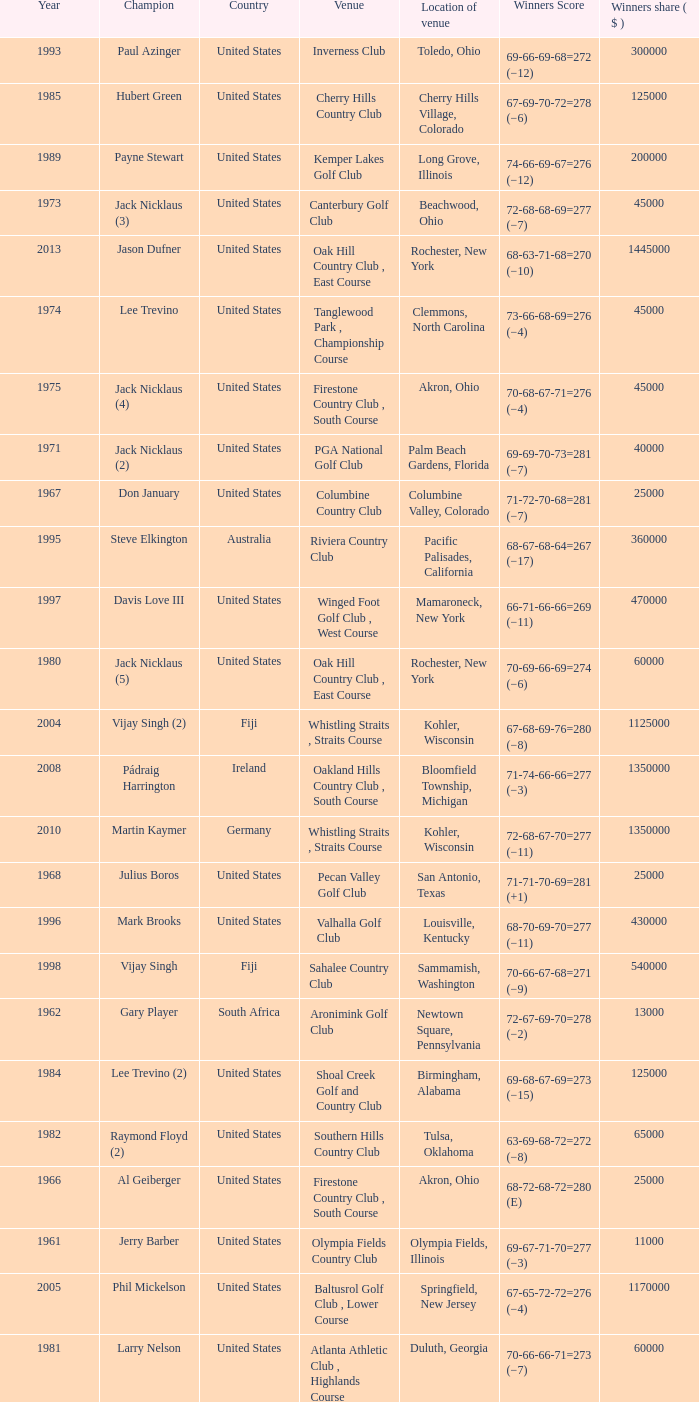Where is the Bellerive Country Club venue located? St. Louis, Missouri. 